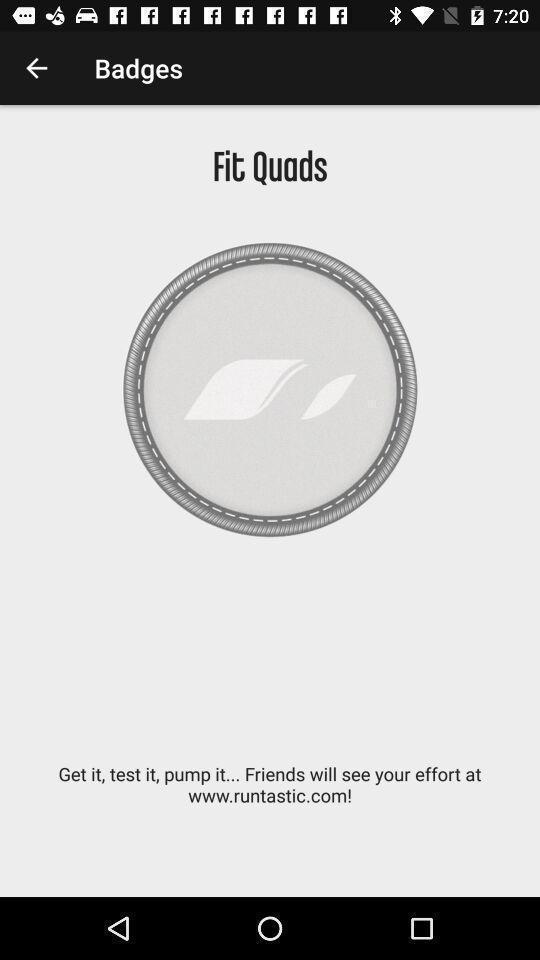Please provide a description for this image. Window displaying a fitness app. 